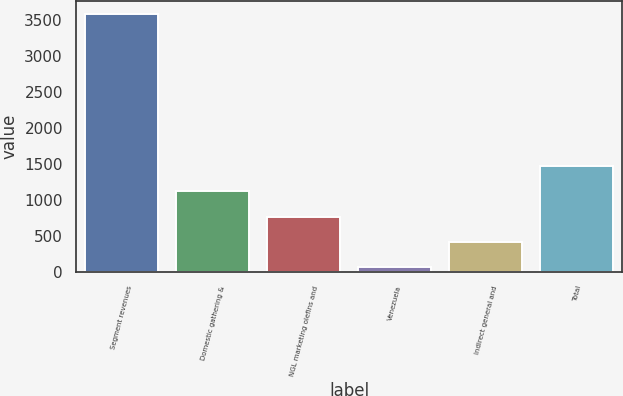<chart> <loc_0><loc_0><loc_500><loc_500><bar_chart><fcel>Segment revenues<fcel>Domestic gathering &<fcel>NGL marketing olefins and<fcel>Venezuela<fcel>Indirect general and<fcel>Total<nl><fcel>3588<fcel>1124<fcel>772<fcel>68<fcel>420<fcel>1476<nl></chart> 